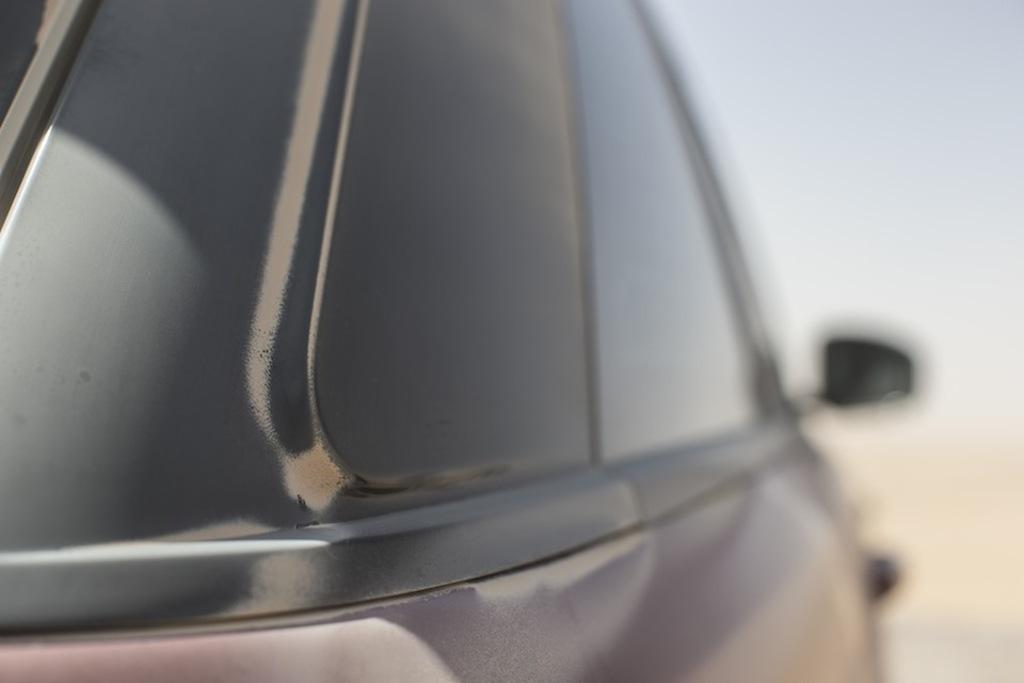What is the main subject of the image? The main subject of the image is a car window. Can you describe the background of the car window? The background of the car window is blurry. What type of coast can be seen through the car window in the image? There is no coast visible through the car window in the image. What type of apparatus is being used by the judge in the image? There is no judge or apparatus present in the image; it only features a car window with a blurry background. 